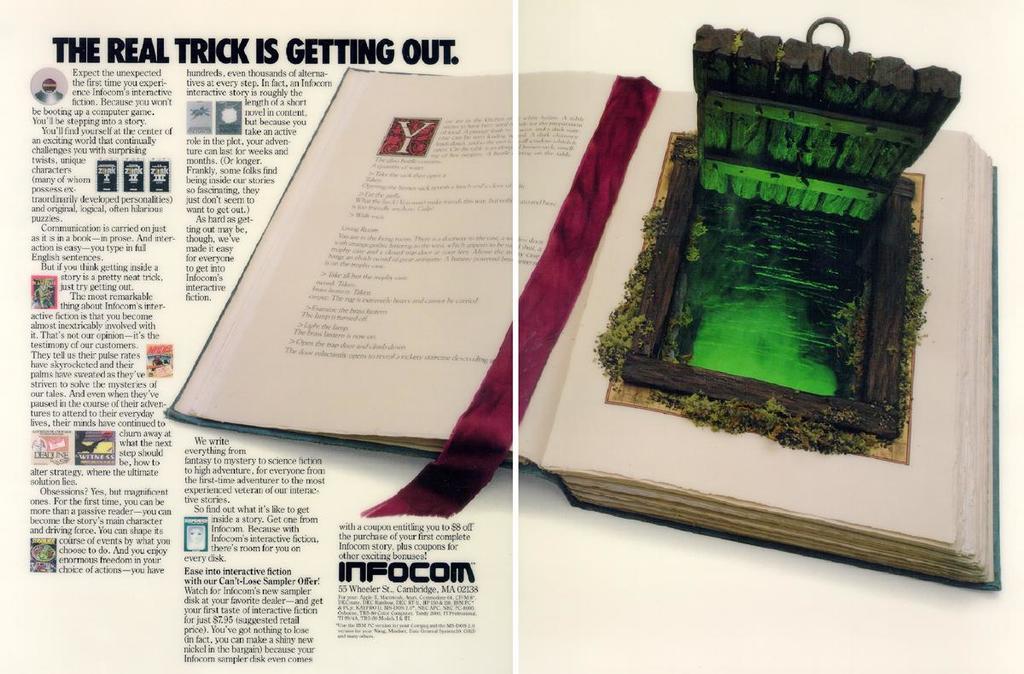What does the book say the real trick is?
Give a very brief answer. Getting out. What is the title of the article?
Provide a succinct answer. The real trick is getting out. 